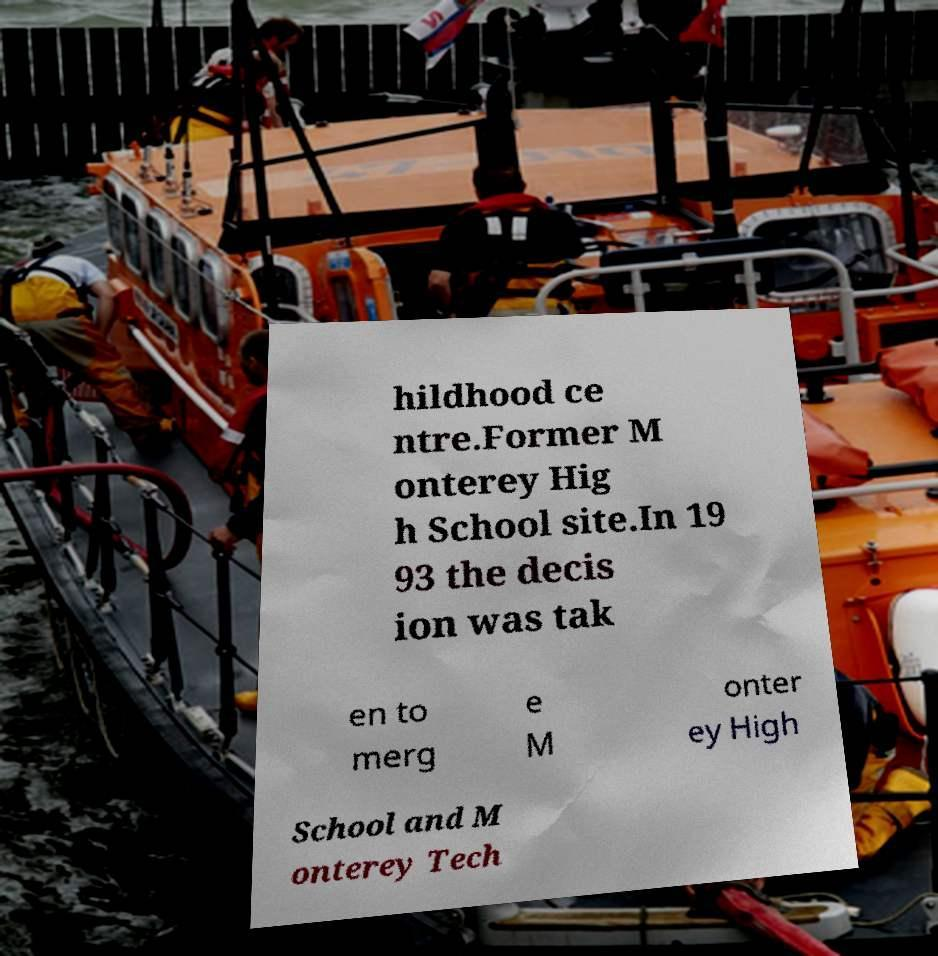There's text embedded in this image that I need extracted. Can you transcribe it verbatim? hildhood ce ntre.Former M onterey Hig h School site.In 19 93 the decis ion was tak en to merg e M onter ey High School and M onterey Tech 